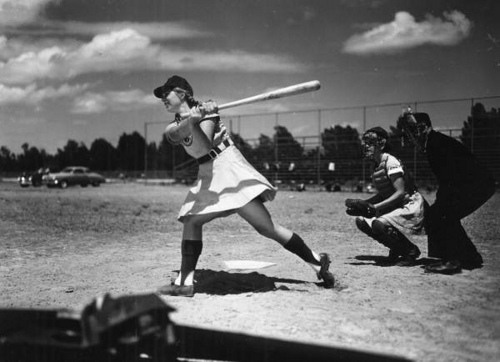<image>What kind of pants is the person wearing? I am not sure what kind of pants the person is wearing. It could be a skort, skirt, or dress. What kind of pants is the person wearing? It is unanswerable what kind of pants the person is wearing. 